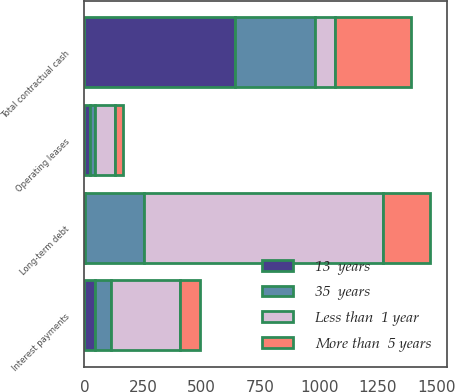Convert chart. <chart><loc_0><loc_0><loc_500><loc_500><stacked_bar_chart><ecel><fcel>Long-term debt<fcel>Operating leases<fcel>Interest payments<fcel>Total contractual cash<nl><fcel>Less than  1 year<fcel>1015.8<fcel>86.2<fcel>295.9<fcel>86.2<nl><fcel>13  years<fcel>2.5<fcel>23.6<fcel>43.8<fcel>641.8<nl><fcel>More than  5 years<fcel>202.3<fcel>34.2<fcel>83.5<fcel>323.1<nl><fcel>35  years<fcel>251.9<fcel>19.5<fcel>67.9<fcel>339.3<nl></chart> 